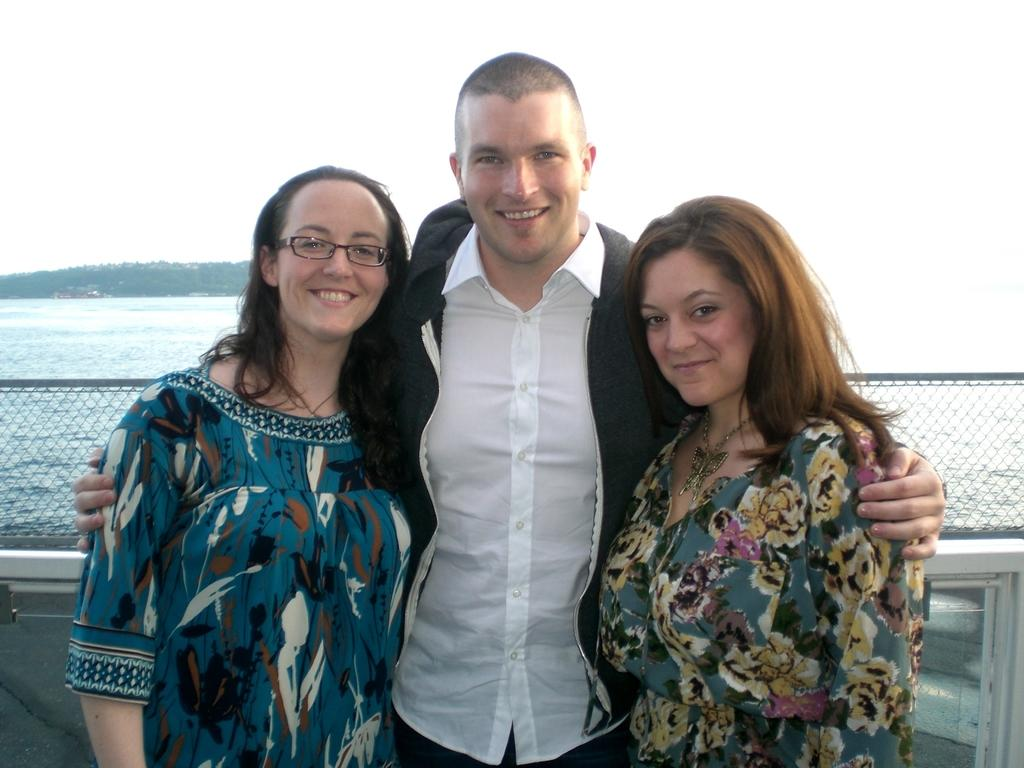How many people are in the image? There are three people in the image. What are the people doing in the image? The people are standing and smiling. What can be seen in the background of the image? The background of the image is white. What is visible in the image besides the people? There is water, a fence, and some objects visible in the image. Can you tell me how many sheep are visible in the image? There are no sheep present in the image. What type of attention are the people in the image giving to the airport? There is no airport present in the image, so it is not possible to determine what type of attention the people might be giving to it. 